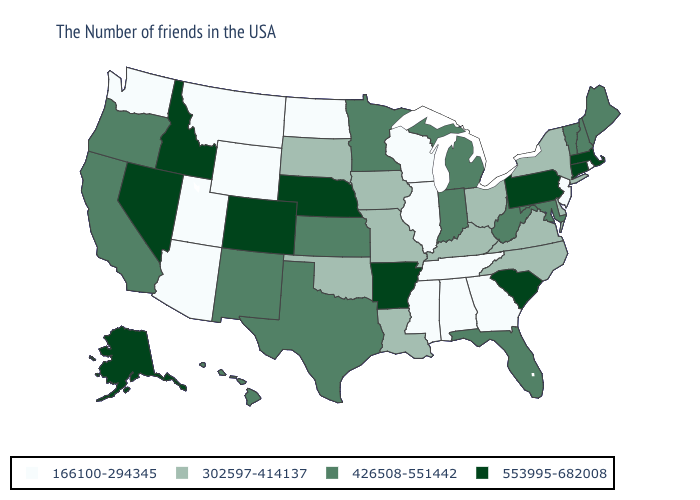What is the value of North Carolina?
Quick response, please. 302597-414137. What is the value of New Mexico?
Give a very brief answer. 426508-551442. Name the states that have a value in the range 166100-294345?
Give a very brief answer. Rhode Island, New Jersey, Georgia, Alabama, Tennessee, Wisconsin, Illinois, Mississippi, North Dakota, Wyoming, Utah, Montana, Arizona, Washington. Does the first symbol in the legend represent the smallest category?
Quick response, please. Yes. Does Wisconsin have a higher value than Massachusetts?
Concise answer only. No. Name the states that have a value in the range 302597-414137?
Keep it brief. New York, Delaware, Virginia, North Carolina, Ohio, Kentucky, Louisiana, Missouri, Iowa, Oklahoma, South Dakota. Among the states that border New Jersey , does New York have the lowest value?
Short answer required. Yes. What is the lowest value in states that border Colorado?
Keep it brief. 166100-294345. How many symbols are there in the legend?
Quick response, please. 4. Among the states that border Mississippi , does Tennessee have the lowest value?
Write a very short answer. Yes. What is the value of Vermont?
Be succinct. 426508-551442. Name the states that have a value in the range 553995-682008?
Answer briefly. Massachusetts, Connecticut, Pennsylvania, South Carolina, Arkansas, Nebraska, Colorado, Idaho, Nevada, Alaska. What is the value of West Virginia?
Write a very short answer. 426508-551442. Which states have the lowest value in the USA?
Keep it brief. Rhode Island, New Jersey, Georgia, Alabama, Tennessee, Wisconsin, Illinois, Mississippi, North Dakota, Wyoming, Utah, Montana, Arizona, Washington. What is the value of Georgia?
Give a very brief answer. 166100-294345. 